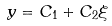<formula> <loc_0><loc_0><loc_500><loc_500>y = C _ { 1 } + C _ { 2 } \xi</formula> 